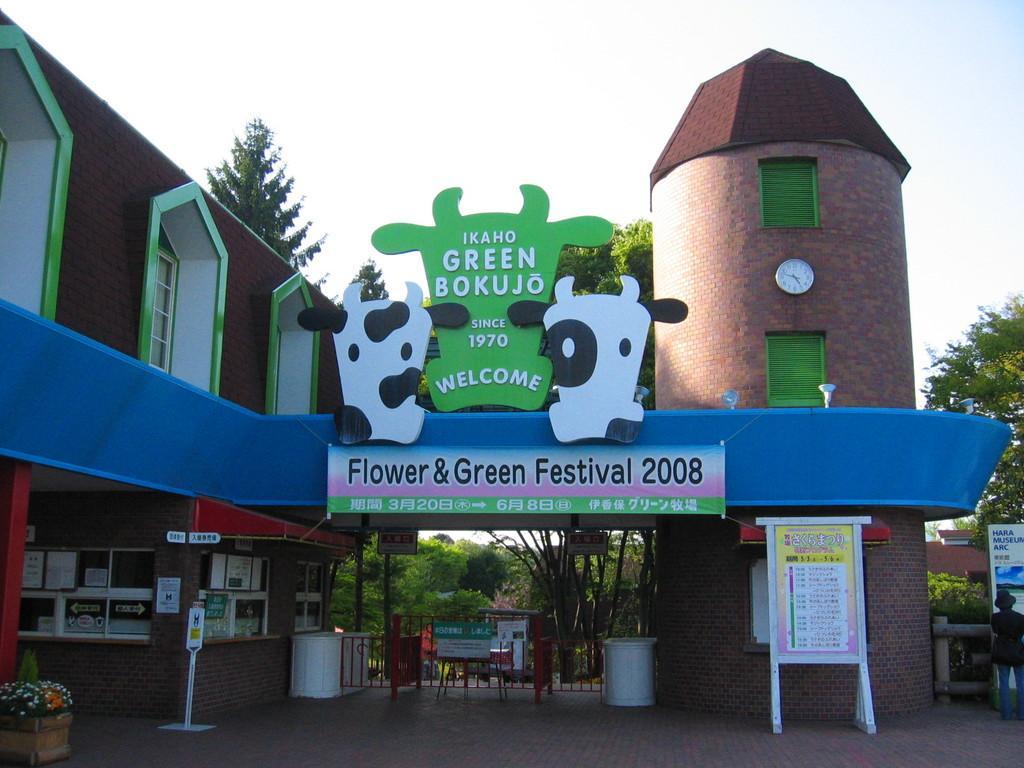Could you give a brief overview of what you see in this image? In this image there is a building with an entrance board and with some text, there are two animal photos on both sides of the entrance board, there are few sign boards, few frames attached to the wall, few trees, houses, chairs, flower pots and the sky. 